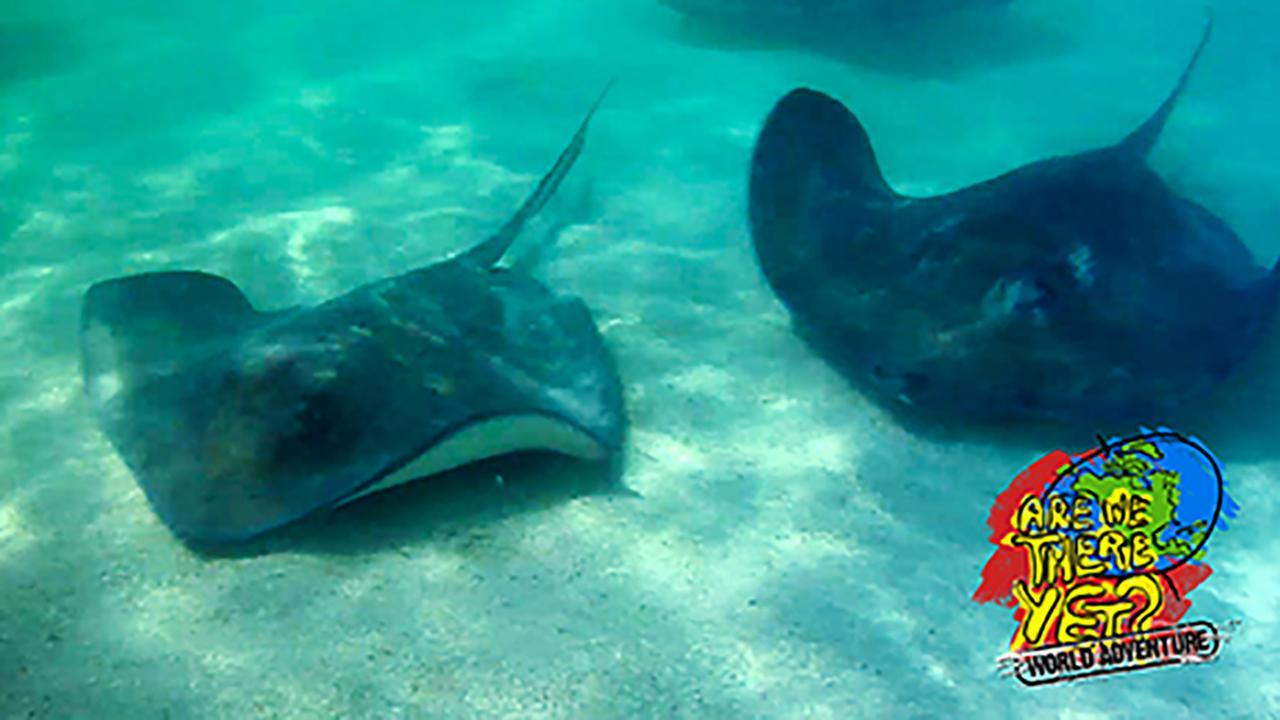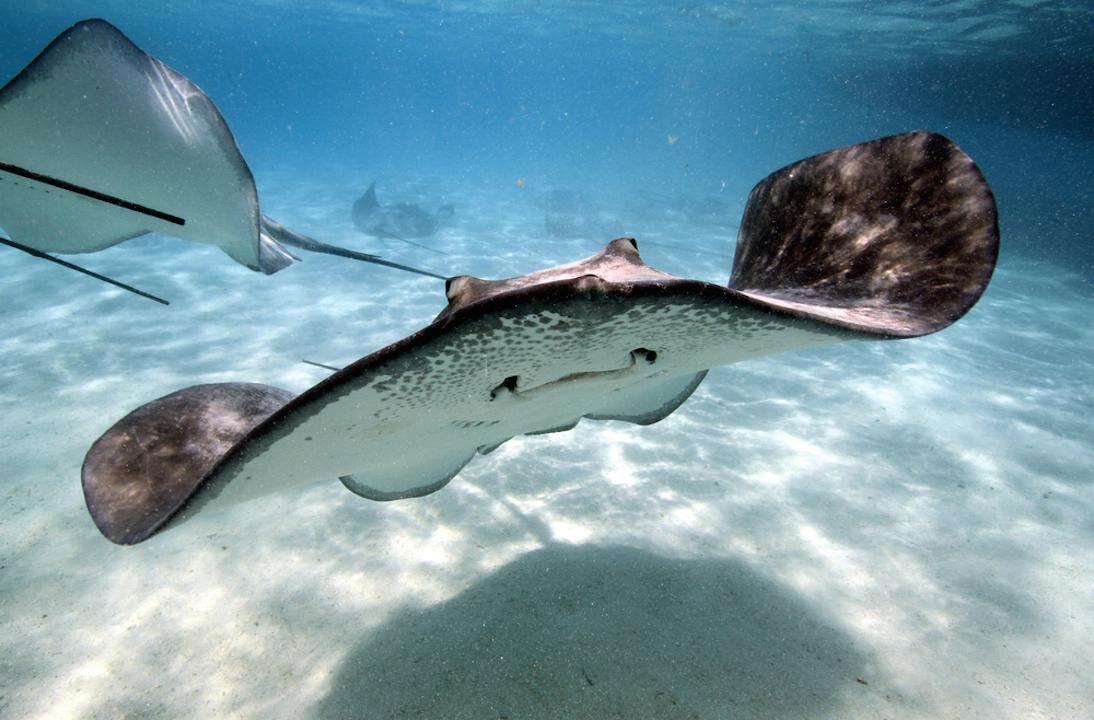The first image is the image on the left, the second image is the image on the right. Examine the images to the left and right. Is the description "There are at least two rays in at least one of the images." accurate? Answer yes or no. Yes. The first image is the image on the left, the second image is the image on the right. Evaluate the accuracy of this statement regarding the images: "A single ray is sitting on the sandy bottom in the image on the left.". Is it true? Answer yes or no. No. The first image is the image on the left, the second image is the image on the right. Examine the images to the left and right. Is the description "An image shows one rightward-facing stingray that is partly covered in sand." accurate? Answer yes or no. No. The first image is the image on the left, the second image is the image on the right. Evaluate the accuracy of this statement regarding the images: "The underside of a stingray, including its mouth, is visible in the right-hand image.". Is it true? Answer yes or no. Yes. 